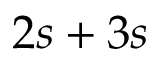Convert formula to latex. <formula><loc_0><loc_0><loc_500><loc_500>2 s + 3 s</formula> 